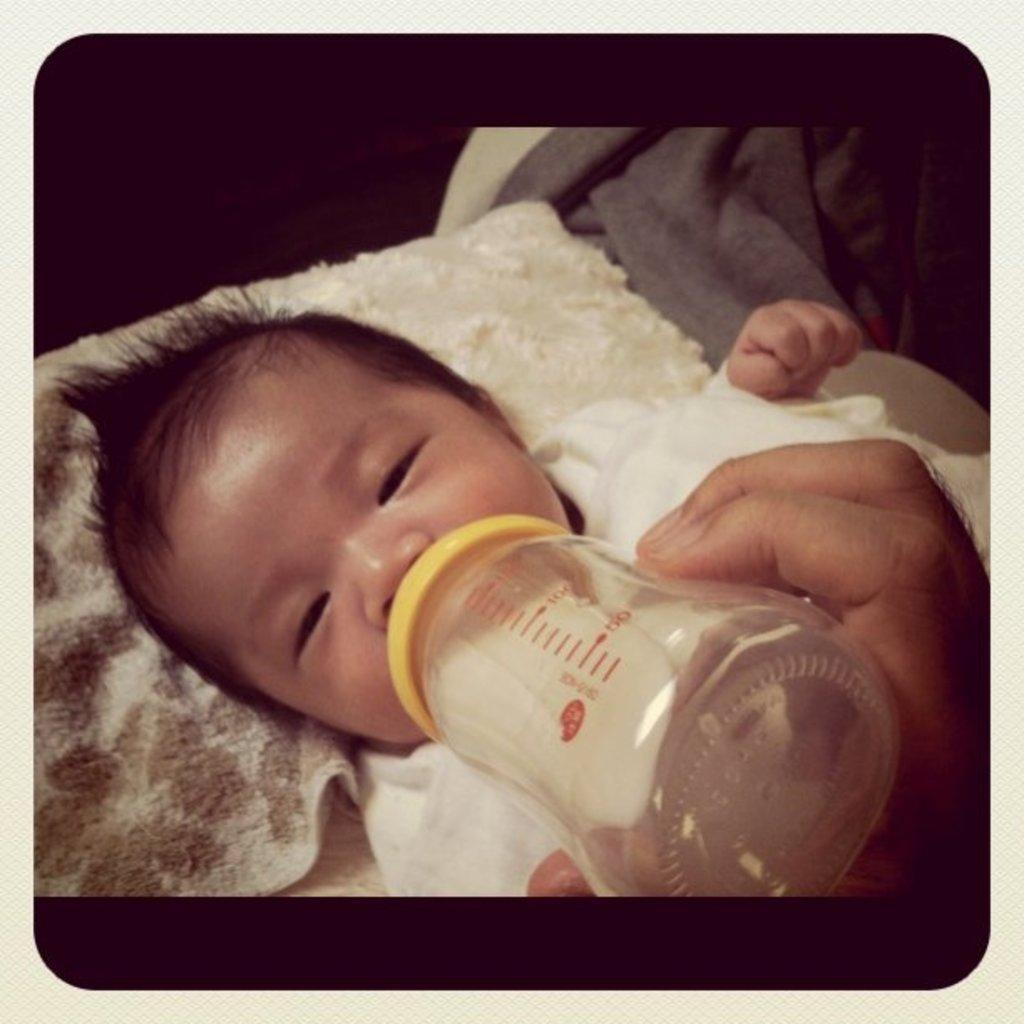In one or two sentences, can you explain what this image depicts? In this image there is a kid sleeping on the bed and drinking the milk which is in the milk bottle. On the right side top there is a blanket. 